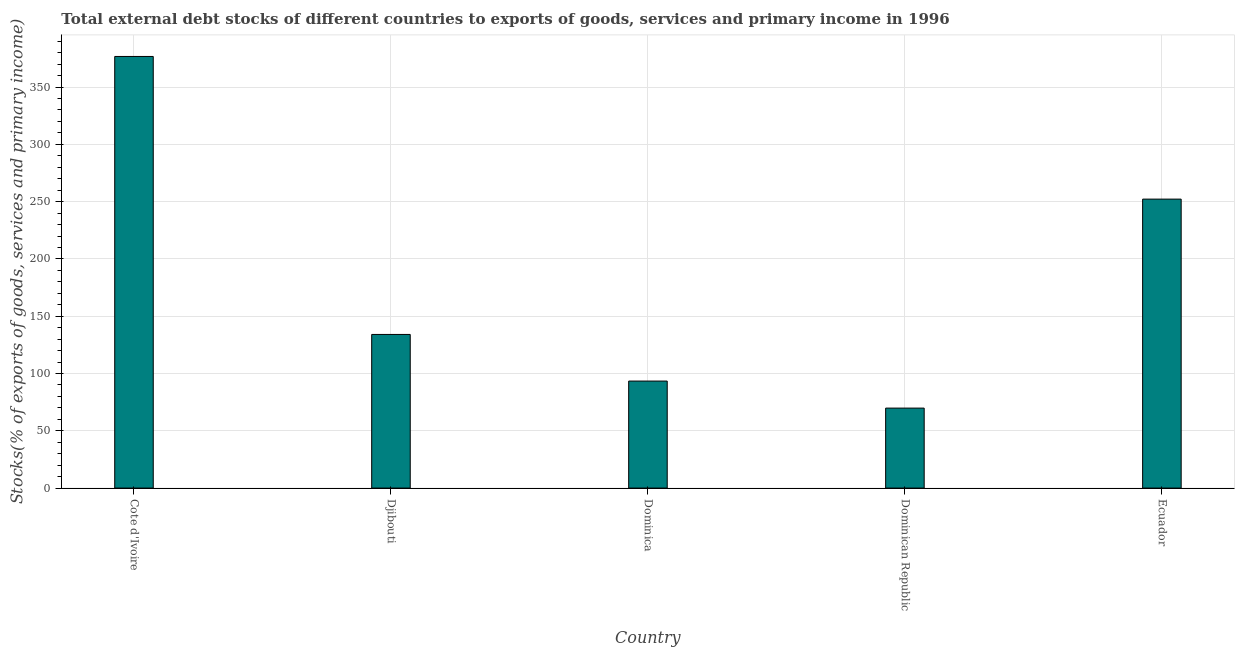Does the graph contain grids?
Provide a short and direct response. Yes. What is the title of the graph?
Your response must be concise. Total external debt stocks of different countries to exports of goods, services and primary income in 1996. What is the label or title of the X-axis?
Keep it short and to the point. Country. What is the label or title of the Y-axis?
Ensure brevity in your answer.  Stocks(% of exports of goods, services and primary income). What is the external debt stocks in Cote d'Ivoire?
Provide a succinct answer. 376.73. Across all countries, what is the maximum external debt stocks?
Your answer should be compact. 376.73. Across all countries, what is the minimum external debt stocks?
Make the answer very short. 69.82. In which country was the external debt stocks maximum?
Offer a very short reply. Cote d'Ivoire. In which country was the external debt stocks minimum?
Offer a very short reply. Dominican Republic. What is the sum of the external debt stocks?
Give a very brief answer. 926.26. What is the difference between the external debt stocks in Dominican Republic and Ecuador?
Offer a terse response. -182.4. What is the average external debt stocks per country?
Give a very brief answer. 185.25. What is the median external debt stocks?
Offer a very short reply. 134.09. In how many countries, is the external debt stocks greater than 270 %?
Offer a very short reply. 1. What is the ratio of the external debt stocks in Dominica to that in Dominican Republic?
Make the answer very short. 1.34. Is the difference between the external debt stocks in Djibouti and Ecuador greater than the difference between any two countries?
Give a very brief answer. No. What is the difference between the highest and the second highest external debt stocks?
Your answer should be compact. 124.51. Is the sum of the external debt stocks in Djibouti and Ecuador greater than the maximum external debt stocks across all countries?
Make the answer very short. Yes. What is the difference between the highest and the lowest external debt stocks?
Ensure brevity in your answer.  306.91. What is the Stocks(% of exports of goods, services and primary income) of Cote d'Ivoire?
Your answer should be very brief. 376.73. What is the Stocks(% of exports of goods, services and primary income) of Djibouti?
Offer a very short reply. 134.09. What is the Stocks(% of exports of goods, services and primary income) in Dominica?
Give a very brief answer. 93.41. What is the Stocks(% of exports of goods, services and primary income) of Dominican Republic?
Your answer should be compact. 69.82. What is the Stocks(% of exports of goods, services and primary income) of Ecuador?
Give a very brief answer. 252.22. What is the difference between the Stocks(% of exports of goods, services and primary income) in Cote d'Ivoire and Djibouti?
Provide a succinct answer. 242.63. What is the difference between the Stocks(% of exports of goods, services and primary income) in Cote d'Ivoire and Dominica?
Give a very brief answer. 283.32. What is the difference between the Stocks(% of exports of goods, services and primary income) in Cote d'Ivoire and Dominican Republic?
Offer a very short reply. 306.91. What is the difference between the Stocks(% of exports of goods, services and primary income) in Cote d'Ivoire and Ecuador?
Keep it short and to the point. 124.51. What is the difference between the Stocks(% of exports of goods, services and primary income) in Djibouti and Dominica?
Make the answer very short. 40.69. What is the difference between the Stocks(% of exports of goods, services and primary income) in Djibouti and Dominican Republic?
Provide a succinct answer. 64.28. What is the difference between the Stocks(% of exports of goods, services and primary income) in Djibouti and Ecuador?
Offer a very short reply. -118.12. What is the difference between the Stocks(% of exports of goods, services and primary income) in Dominica and Dominican Republic?
Your answer should be compact. 23.59. What is the difference between the Stocks(% of exports of goods, services and primary income) in Dominica and Ecuador?
Your answer should be very brief. -158.81. What is the difference between the Stocks(% of exports of goods, services and primary income) in Dominican Republic and Ecuador?
Your answer should be very brief. -182.4. What is the ratio of the Stocks(% of exports of goods, services and primary income) in Cote d'Ivoire to that in Djibouti?
Offer a very short reply. 2.81. What is the ratio of the Stocks(% of exports of goods, services and primary income) in Cote d'Ivoire to that in Dominica?
Ensure brevity in your answer.  4.03. What is the ratio of the Stocks(% of exports of goods, services and primary income) in Cote d'Ivoire to that in Dominican Republic?
Offer a terse response. 5.4. What is the ratio of the Stocks(% of exports of goods, services and primary income) in Cote d'Ivoire to that in Ecuador?
Provide a succinct answer. 1.49. What is the ratio of the Stocks(% of exports of goods, services and primary income) in Djibouti to that in Dominica?
Ensure brevity in your answer.  1.44. What is the ratio of the Stocks(% of exports of goods, services and primary income) in Djibouti to that in Dominican Republic?
Your answer should be very brief. 1.92. What is the ratio of the Stocks(% of exports of goods, services and primary income) in Djibouti to that in Ecuador?
Provide a short and direct response. 0.53. What is the ratio of the Stocks(% of exports of goods, services and primary income) in Dominica to that in Dominican Republic?
Offer a very short reply. 1.34. What is the ratio of the Stocks(% of exports of goods, services and primary income) in Dominica to that in Ecuador?
Offer a very short reply. 0.37. What is the ratio of the Stocks(% of exports of goods, services and primary income) in Dominican Republic to that in Ecuador?
Your answer should be compact. 0.28. 